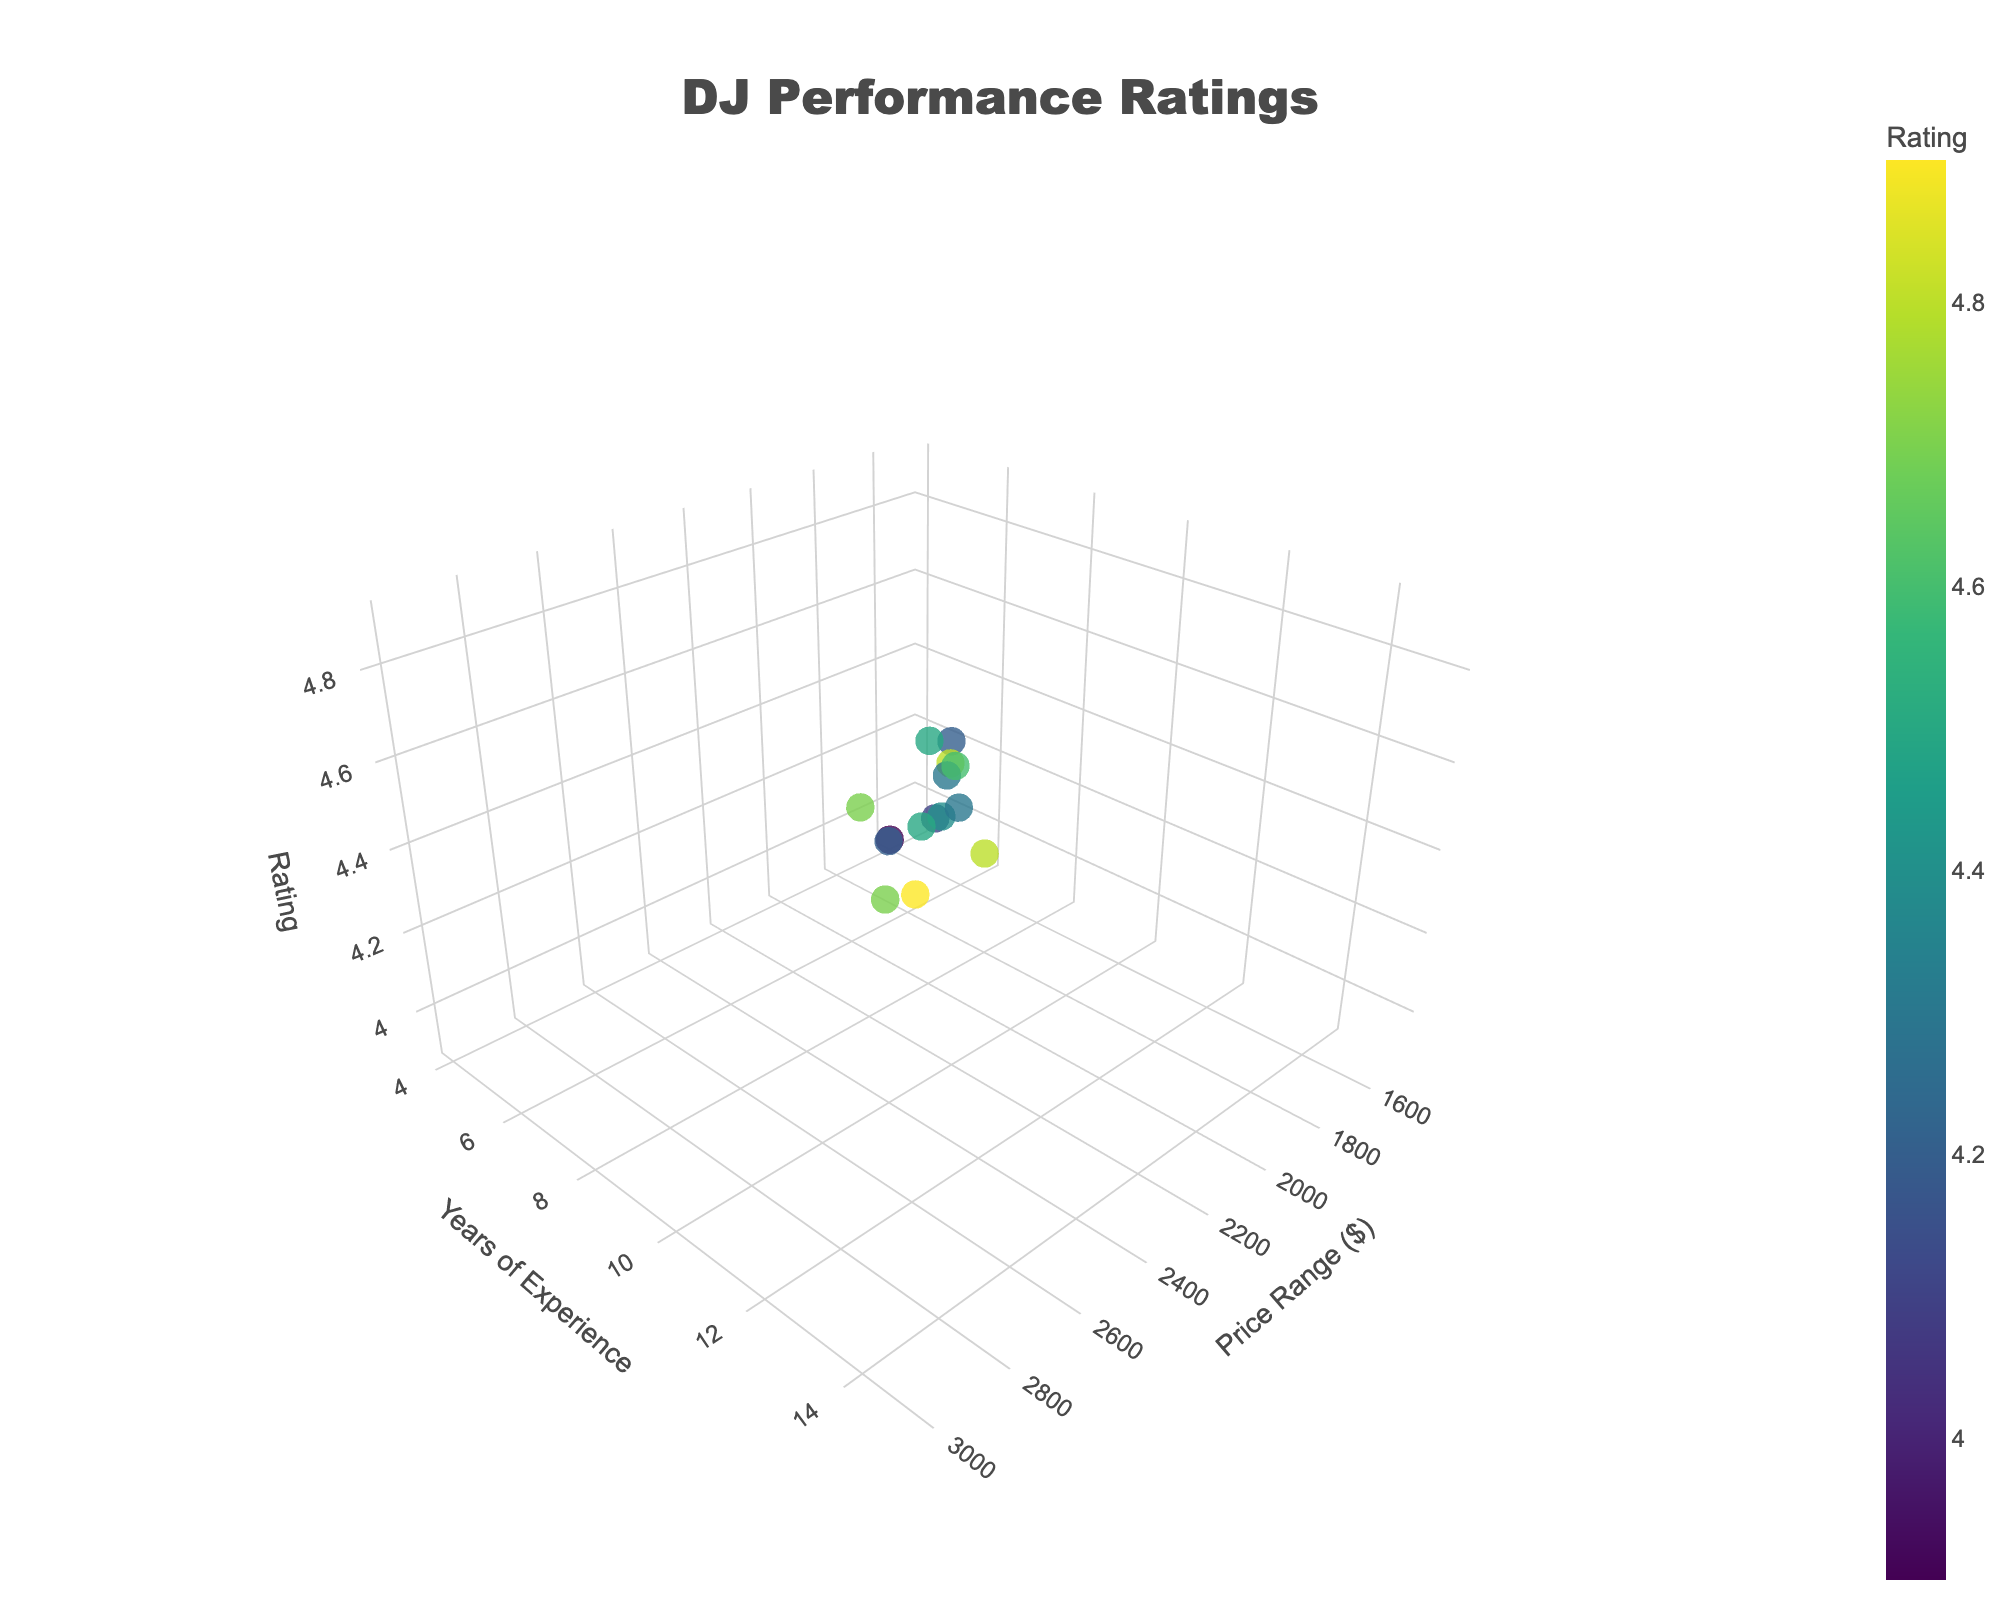How many DJs are represented in the figure? The plot shows one data point for each DJ, so by counting the data points, we find the total number of DJs. The dataset contains 15 different DJ names.
Answer: 15 Which DJ has the highest rating and what is their price range? By looking at the highest point on the z-axis (Rating), Mix Master Mike has the highest rating of 4.9. From the dataset, Mix Master Mike's price range is $3000.
Answer: Mix Master Mike, $3000 What is the price range of DJs with over 10 years of experience? Identify the points on the y-axis representing years of experience greater than 10. The DJs meeting this criterion are Rhythm Revolution ($2500), Harmony Heroes ($2800), Vinyl Virtuosos ($2600), and Bass Droppers ($2700).
Answer: $2500 - $2800 Which DJ has the lowest rating and how many years of experience do they have? Locate the lowest data point on the z-axis (Rating). The lowest rating is 3.9 by Disco Inferno, who has 4 years of experience.
Answer: Disco Inferno, 4 years Are there any DJs with a rating of 4.5 and what is their price range? Check for data points on the z-axis at the 4.5 level. Beats by Bailey and Melody Makers both have ratings of 4.5. Their price ranges are $2000 and $2300, respectively.
Answer: Beats by Bailey ($2000), Melody Makers ($2300) What is the average rating of DJs with a price range between $2000 and $2500? Identify DJs within the price range $2000 - $2500 and find their ratings: Beats by Bailey (4.5), Soundwave Solutions (4.3), Turntable Titans (4.6), and Rhythm Revolution (4.8). Sum the ratings and divide by the number of DJs: (4.5 + 4.3 + 4.6 + 4.8) / 4 = 18.2 / 4 = 4.55.
Answer: 4.55 How does the rating of DJs with 8 years of experience compare to those with 10 years of experience? Identify DJs with 8 and 10 years of experience: 8 years - Beats by Bailey (4.5) and Sonic Sensations (4.3); 10 years - Turntable Titans (4.6) and Melody Makers (4.5). Average ratings: 8 years - (4.5 + 4.3)/2 = 4.4, 10 years - (4.6 + 4.5)/2 = 4.55. DJs with 10 years of experience have a higher average rating.
Answer: 10 years have higher average rating Is there a correlation between price range and rating? Visually inspect the plot to see if higher-priced DJs tend to have higher ratings. Observe that DJs with higher price ranges generally have higher ratings, indicating a positive correlation.
Answer: Positive correlation What is the range of years of experience for DJs with a rating of 4.7 or higher? Identify DJs with ratings of 4.7 or higher: Rhythm Revolution (12 years), Harmony Heroes (13 years), Vinyl Virtuosos (11 years), and Bass Droppers (14 years). The range is 11 to 14 years.
Answer: 11 to 14 years 